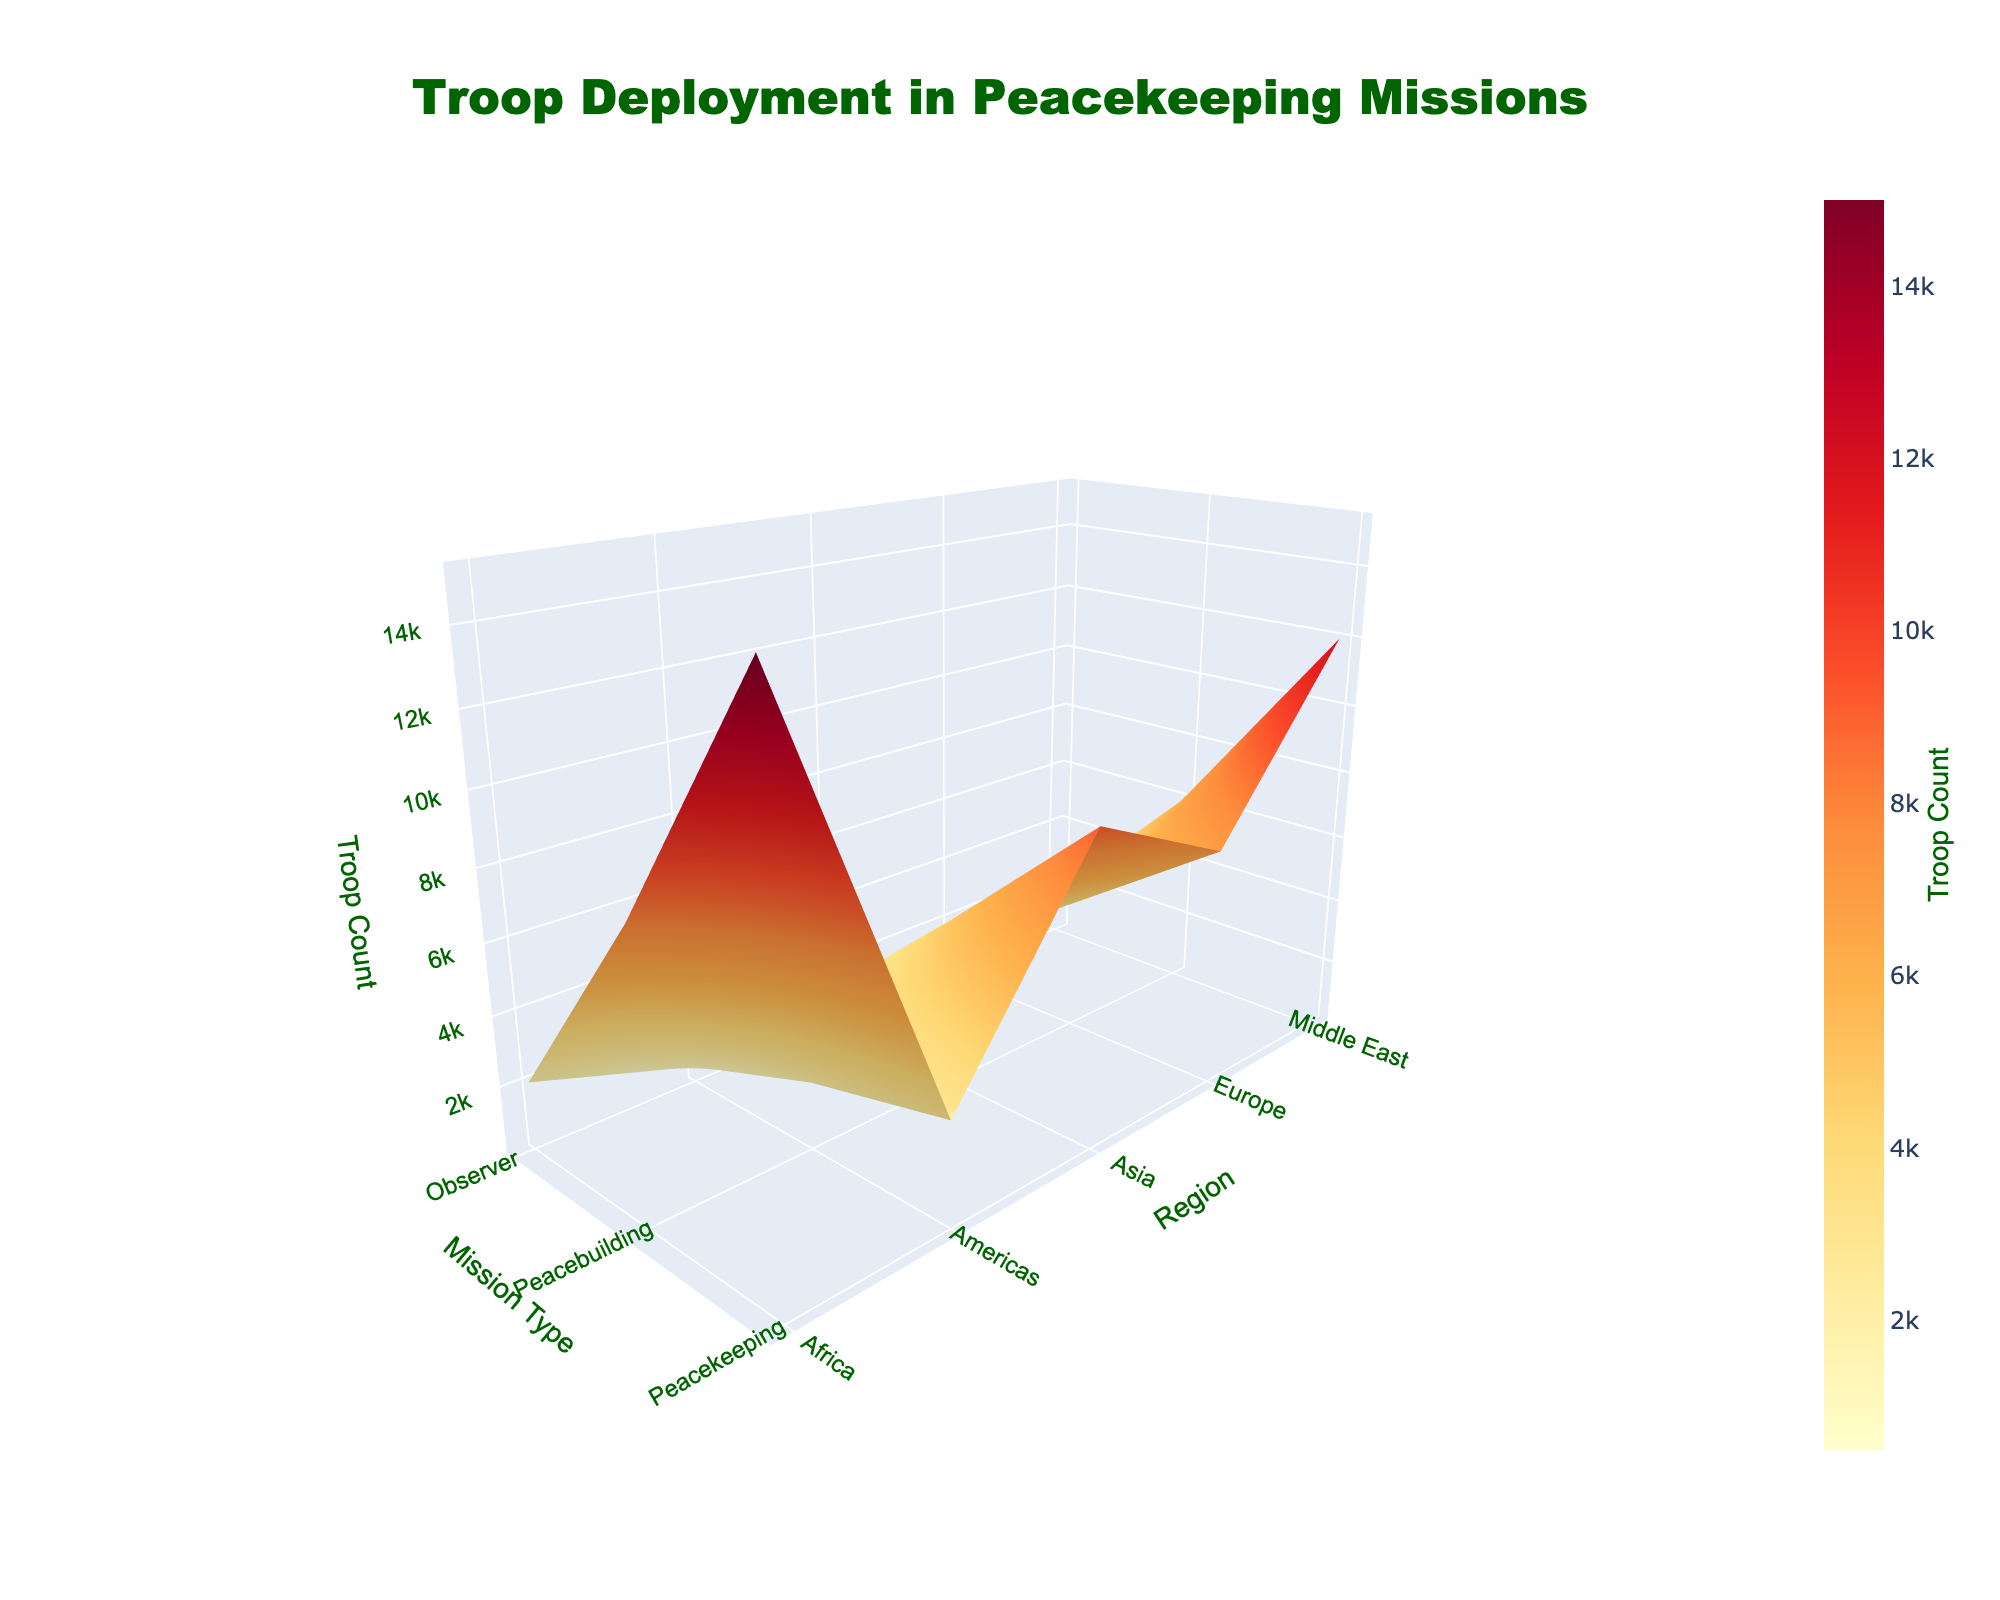What is the highest troop count in the 'Peacekeeping' mission type? First, locate the 'Peacekeeping' mission type on the x-axis. Then, find the highest bar in the 'Peacekeeping' column along the z-axis.
Answer: 15000 Which region has the lowest troop count in 'Observer' missions? Locate the 'Observer' mission type on the x-axis. Find the shortest bar in the 'Observer' column along the z-axis and identify its corresponding region on the y-axis.
Answer: Americas How many regions are represented in the surface plot? Count the unique entries on the y-axis, which represent different regions.
Answer: 5 What is the overall trend in troop count as we move from 'Peacekeeping' to 'Observer' missions? Compare the heights of the bars from the 'Peacekeeping' to 'Observer' mission types. Notice whether the bars generally decrease or increase in height.
Answer: Decreasing Which region shows the most significant difference in troop counts between 'Peacekeeping' and 'Peacebuilding' missions? For each region on the y-axis, compare the troop counts of 'Peacekeeping' and 'Peacebuilding' missions by measuring the difference. Find the region with the largest difference.
Answer: Africa Which mission type has the highest overall average troop count across all regions? For each mission type, sum the troop counts across all regions and divide by the number of regions. Compare the resultant averages to identify the highest one.
Answer: Peacekeeping How does the 'Peacebuilding' troop count in Europe compare to that in Asia? Find the 'Peacebuilding' mission type on the x-axis and compare the heights of the bars corresponding to Europe and Asia on the y-axis.
Answer: Lower in Europe What is the sum of troop counts for 'Observer' missions across all regions? Locate the 'Observer' mission type on the x-axis, and sum the heights of all bars in this column.
Answer: 8200 How does the troop count in 'Peacekeeping' missions in Africa compare to that in the Middle East? Find the 'Peacekeeping' mission type on the x-axis and compare the heights of the bars corresponding to Africa and the Middle East on the y-axis.
Answer: Higher in Africa 